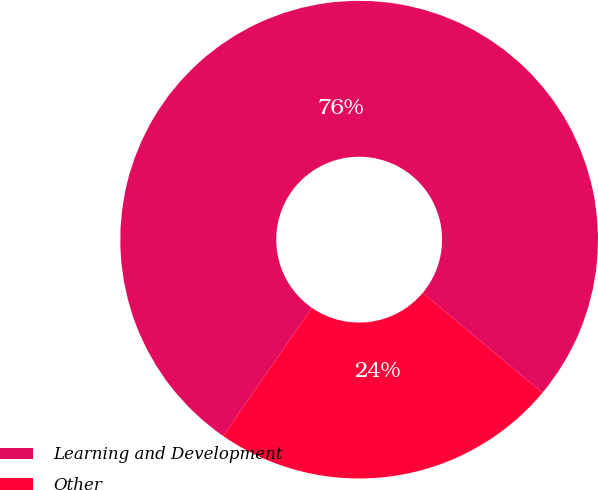Convert chart. <chart><loc_0><loc_0><loc_500><loc_500><pie_chart><fcel>Learning and Development<fcel>Other<nl><fcel>76.43%<fcel>23.57%<nl></chart> 